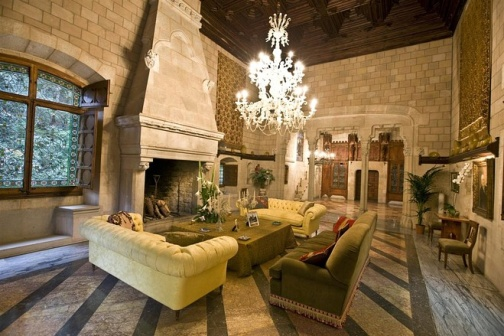What do you think is going on in this snapshot? This snapshot captures a moment of tranquil luxury within an ornately designed living room. The chandelier casts an inviting glow, accentuating soaring ceilings that contribute to the room's openness and grandeur. With comfortable, plush seating, arranged to facilitate conversation, the room is clearly designed for relaxing and socializing. Natural light pours in from an expansive window, offering a serene view of the outdoors. The large stone fireplace, dominating one side of the room, becomes a focal point, promising warmth and ambiance. While the furnishings reflect an opulence that suggests this space is for formal entertaining, there is also an air of welcome that pervades the setup, inviting one to sit down and enjoy the luxurious surroundings. 